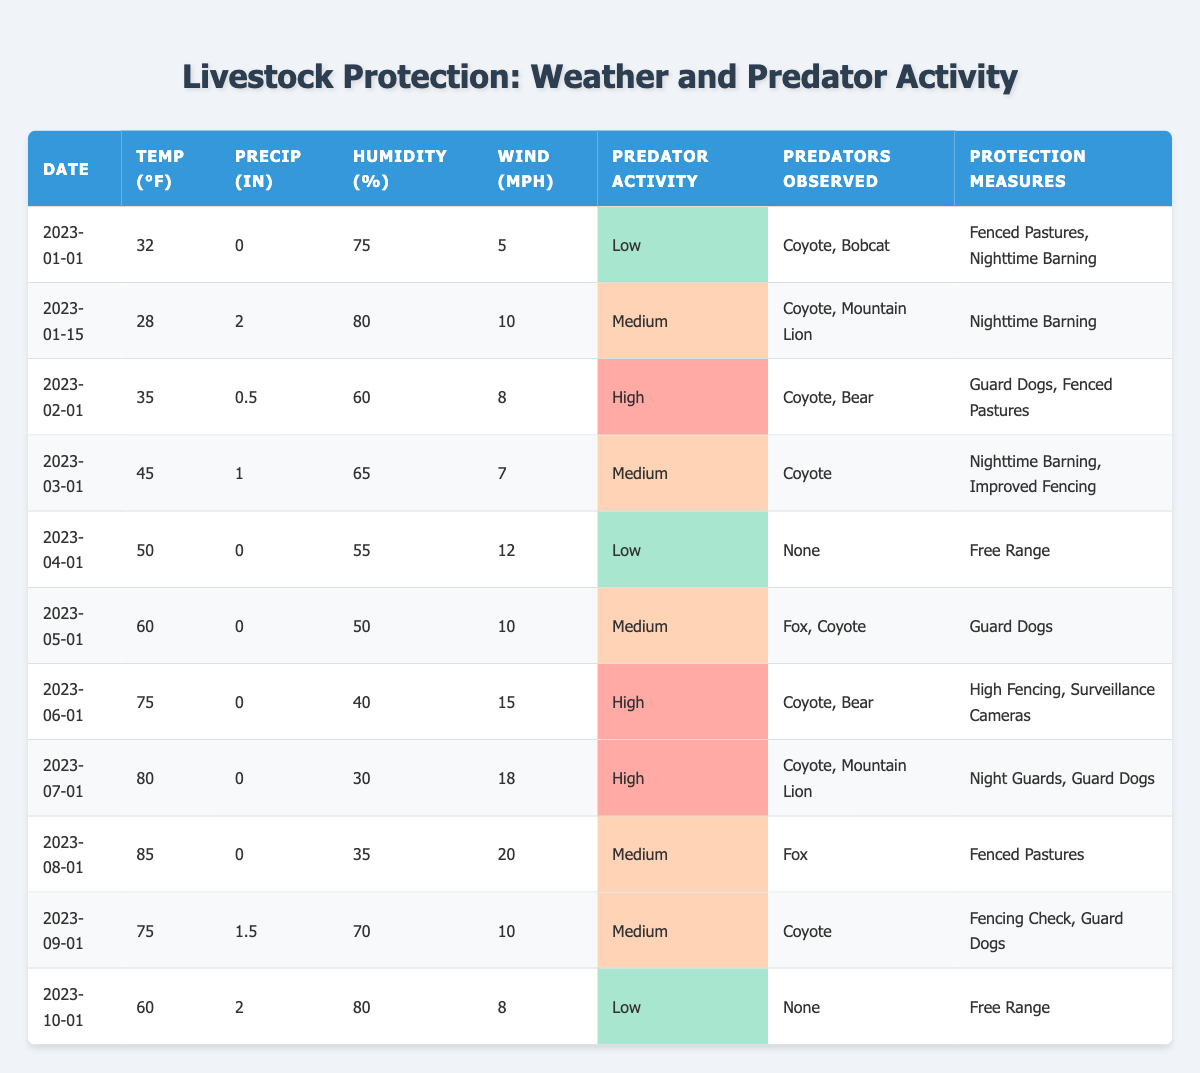What is the highest predator activity level recorded in the table? The table lists the predator activity levels as Low, Medium, and High. Scanning through the table, I see that the highest recorded level is High, which appears in the entries for February, June, and July.
Answer: High On which date was the lowest recorded temperature? The table shows temperature readings for each date, where the lowest value is 28°F on January 15.
Answer: January 15 How many times were "Guard Dogs" mentioned as a protection measure? By counting the entries in the column for Livestock Protection Measures, "Guard Dogs" appears on the following dates: January 1, February 1, May 1, June 1, July 1, and September 1, totaling 5 mentions.
Answer: 5 What was the average humidity when the predator activity level was High? The table shows High activity levels on February 1 (60% humidity), June 1 (40% humidity), and July 1 (30% humidity). Adding these gives 60 + 40 + 30 = 130; dividing by 3 data points results in an average of 43.33%.
Answer: 43.33% Did any day have a predator activity level of Low while experiencing a temperature above 60°F? Reviewing the table, I find low activity levels on January 1 (32°F), April 1 (50°F), and October 1 (60°F). None of these dates have a temperature above 60°F while also being Low.
Answer: No On which date did predators such as Coyote and Bear appear together? The table shows that both Coyote and Bear were observed on February 1, where the activity level was High.
Answer: February 1 What is the difference in precipitation between June 1 and September 1? The table lists precipitation on June 1 as 0 inches and on September 1 as 1.5 inches. The difference is calculated as 1.5 - 0 = 1.5 inches.
Answer: 1.5 inches Is there a correlation between higher temperatures and an increase in predator activity? By examining the entries, I note that high temperatures (above 60°F) correlate with both Medium and High predator activity levels in June and July, indicating a trend of more activity during warmer months.
Answer: Yes What livestock protection measures were taken when the predator activity was Medium? The Table shows protection measures on the dates with Medium level (January 15, March 1, May 1, August 1, September 1): Nighttime Barning, Improved Fencing, Guard Dogs, Fenced Pastures, and Fencing Check.
Answer: Nighttime Barning, Improved Fencing, Guard Dogs, Fenced Pastures, Fencing Check When was the highest humidity recorded and what was the predator activity level on that date? The highest humidity recorded was 80% on January 15, where the predator activity level was Medium.
Answer: January 15, Medium 